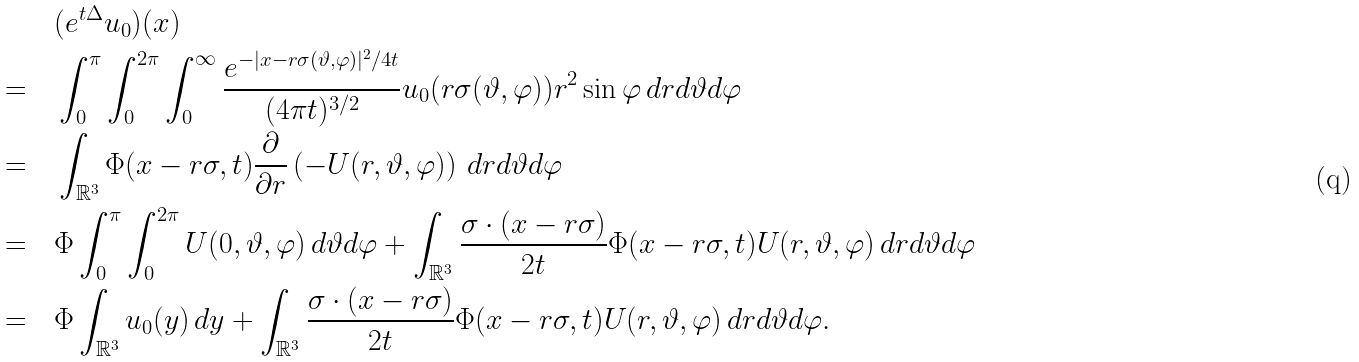Convert formula to latex. <formula><loc_0><loc_0><loc_500><loc_500>& \quad ( e ^ { t \Delta } u _ { 0 } ) ( x ) \\ = & \quad \int _ { 0 } ^ { \pi } \int _ { 0 } ^ { 2 \pi } \int _ { 0 } ^ { \infty } \frac { e ^ { - | x - r \sigma ( \vartheta , \varphi ) | ^ { 2 } / 4 t } } { ( 4 \pi t ) ^ { 3 / 2 } } u _ { 0 } ( r \sigma ( \vartheta , \varphi ) ) r ^ { 2 } \sin \varphi \, d r d \vartheta d \varphi \\ = & \quad \int _ { \mathbb { R } ^ { 3 } } \Phi ( x - r \sigma , t ) \frac { \partial } { \partial r } \left ( - U ( r , \vartheta , \varphi ) \right ) \, d r d \vartheta d \varphi \\ = & \quad \Phi \int _ { 0 } ^ { \pi } \int _ { 0 } ^ { 2 \pi } U ( 0 , \vartheta , \varphi ) \, d \vartheta d \varphi + \int _ { \mathbb { R } ^ { 3 } } \frac { \sigma \cdot ( x - r \sigma ) } { 2 t } \Phi ( x - r \sigma , t ) U ( r , \vartheta , \varphi ) \, d r d \vartheta d \varphi \\ = & \quad \Phi \int _ { \mathbb { R } ^ { 3 } } u _ { 0 } ( y ) \, d y + \int _ { \mathbb { R } ^ { 3 } } \frac { \sigma \cdot ( x - r \sigma ) } { 2 t } \Phi ( x - r \sigma , t ) U ( r , \vartheta , \varphi ) \, d r d \vartheta d \varphi .</formula> 